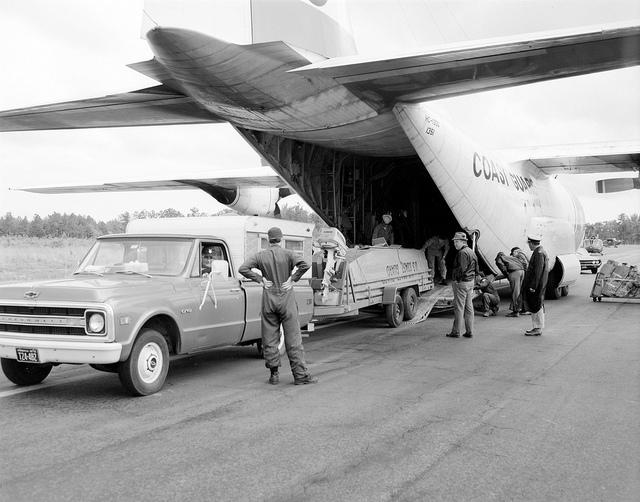What are the men doing?
Be succinct. Loading aircraft. Is this the airport?
Be succinct. Yes. What brand is the pickup truck?
Quick response, please. Chevrolet. 